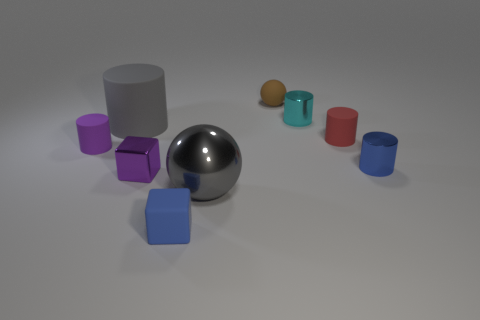Subtract all cubes. How many objects are left? 7 Subtract all tiny shiny cylinders. How many cylinders are left? 3 Subtract 5 cylinders. How many cylinders are left? 0 Subtract all blue cubes. Subtract all green spheres. How many cubes are left? 1 Subtract all purple blocks. How many yellow cylinders are left? 0 Subtract all small red cylinders. Subtract all blue rubber cubes. How many objects are left? 7 Add 6 small blue objects. How many small blue objects are left? 8 Add 3 large cylinders. How many large cylinders exist? 4 Add 1 tiny purple objects. How many objects exist? 10 Subtract all gray cylinders. How many cylinders are left? 4 